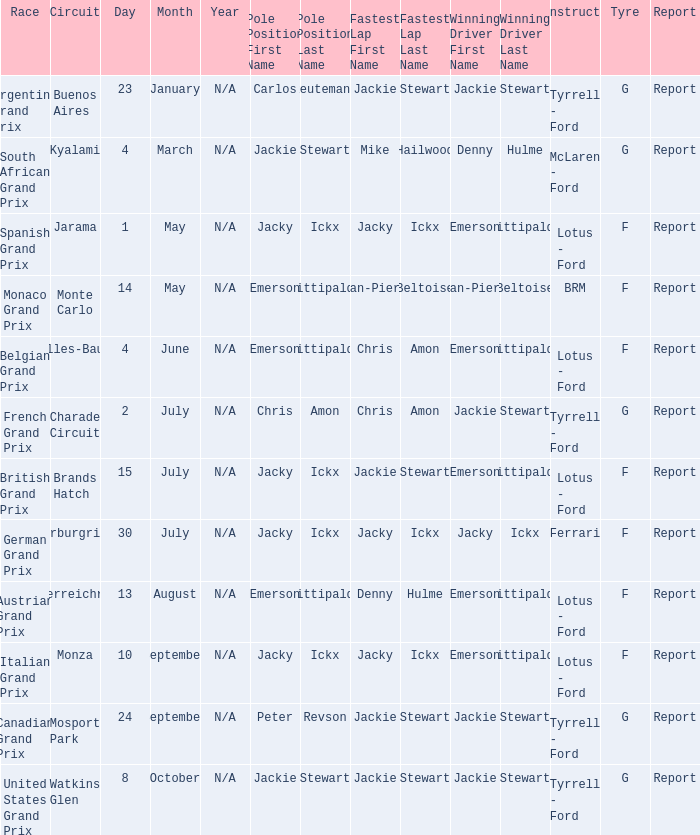When did the Argentine Grand Prix race? 23 January. 